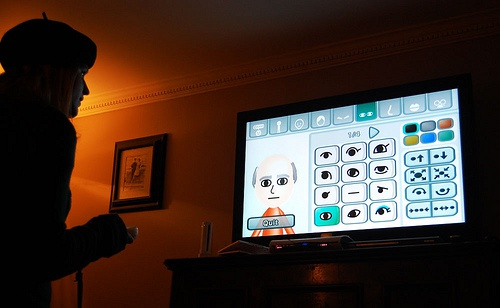Describe the objects in this image and their specific colors. I can see tv in maroon, white, black, lightblue, and teal tones, people in maroon, black, red, and brown tones, and remote in maroon, black, and gray tones in this image. 